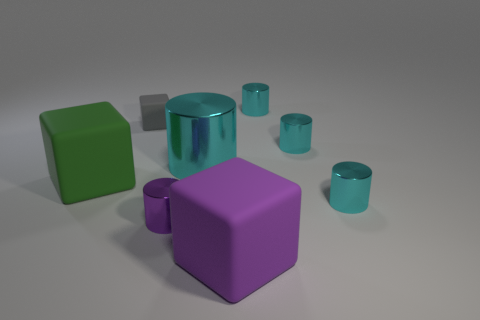What is the block that is behind the big rubber cube behind the rubber object in front of the big green matte block made of?
Give a very brief answer. Rubber. Do the purple object to the left of the purple cube and the large cyan object have the same shape?
Offer a terse response. Yes. There is a big block that is on the left side of the purple rubber thing; what is it made of?
Keep it short and to the point. Rubber. How many metallic objects are either small blocks or green blocks?
Provide a succinct answer. 0. Are there any cyan shiny cylinders that have the same size as the purple cylinder?
Your answer should be very brief. Yes. Are there more small metallic cylinders that are in front of the small purple cylinder than yellow shiny cylinders?
Provide a short and direct response. No. How many tiny things are either cyan objects or blocks?
Provide a succinct answer. 4. What number of big green things have the same shape as the large purple thing?
Your answer should be compact. 1. What is the green block that is left of the small shiny object that is behind the gray matte object made of?
Offer a terse response. Rubber. How big is the rubber block that is right of the purple metal cylinder?
Give a very brief answer. Large. 